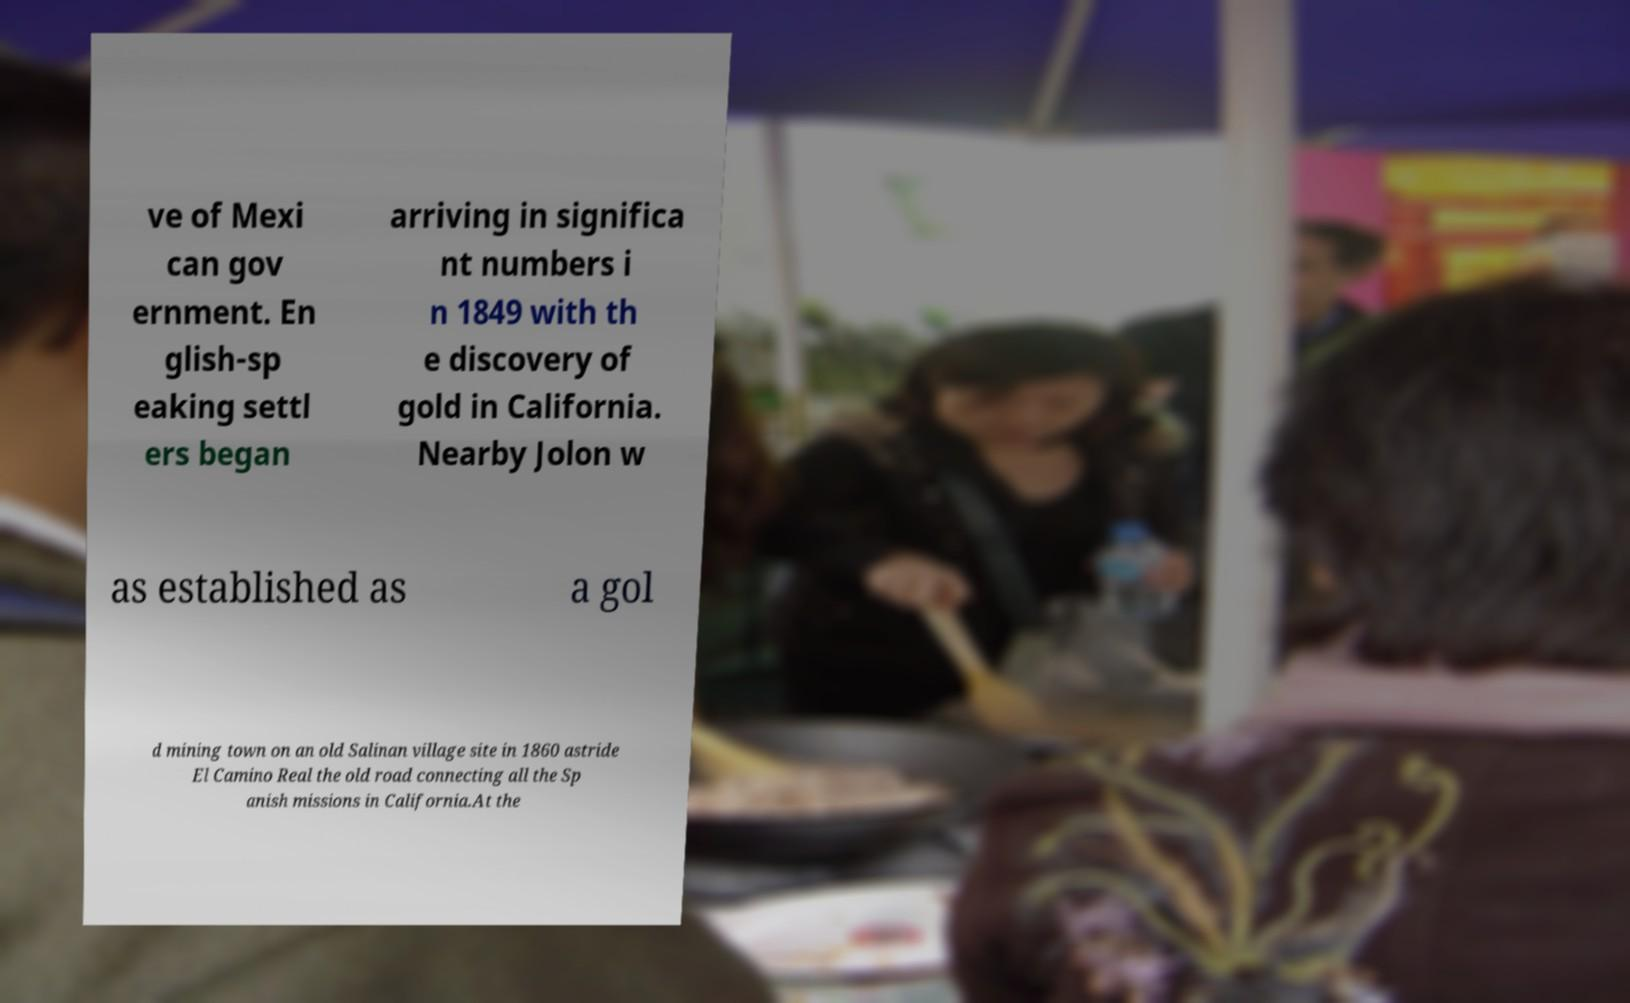Could you extract and type out the text from this image? ve of Mexi can gov ernment. En glish-sp eaking settl ers began arriving in significa nt numbers i n 1849 with th e discovery of gold in California. Nearby Jolon w as established as a gol d mining town on an old Salinan village site in 1860 astride El Camino Real the old road connecting all the Sp anish missions in California.At the 